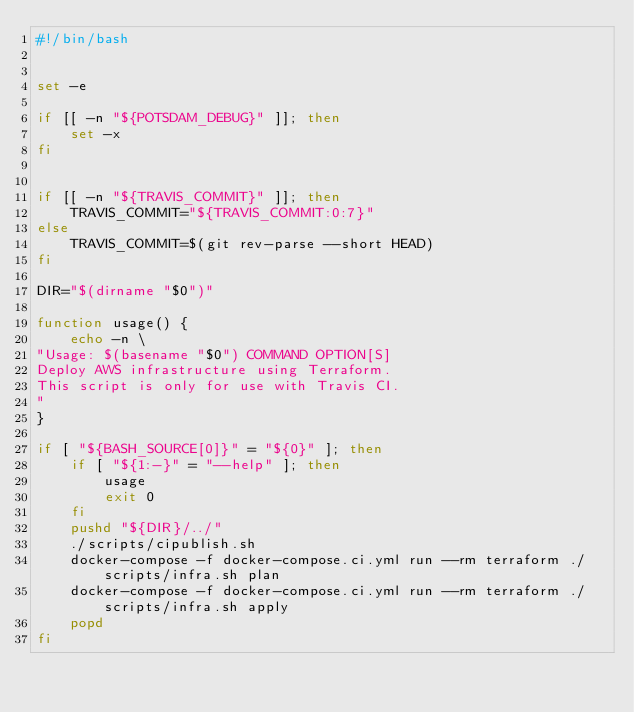<code> <loc_0><loc_0><loc_500><loc_500><_Bash_>#!/bin/bash


set -e

if [[ -n "${POTSDAM_DEBUG}" ]]; then
    set -x
fi


if [[ -n "${TRAVIS_COMMIT}" ]]; then
    TRAVIS_COMMIT="${TRAVIS_COMMIT:0:7}"
else
    TRAVIS_COMMIT=$(git rev-parse --short HEAD)
fi

DIR="$(dirname "$0")"

function usage() {
    echo -n \
"Usage: $(basename "$0") COMMAND OPTION[S]
Deploy AWS infrastructure using Terraform.
This script is only for use with Travis CI.
"
}

if [ "${BASH_SOURCE[0]}" = "${0}" ]; then
    if [ "${1:-}" = "--help" ]; then
        usage
        exit 0
    fi
    pushd "${DIR}/../"
    ./scripts/cipublish.sh
    docker-compose -f docker-compose.ci.yml run --rm terraform ./scripts/infra.sh plan
    docker-compose -f docker-compose.ci.yml run --rm terraform ./scripts/infra.sh apply
    popd
fi</code> 